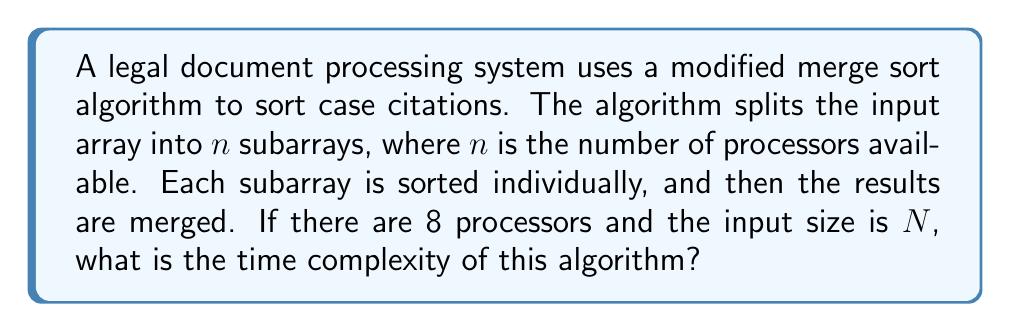Could you help me with this problem? To analyze the time complexity of this modified merge sort algorithm, we need to consider the following steps:

1. Splitting the input:
   The input of size $N$ is split into 8 subarrays (since there are 8 processors). This operation takes $O(N)$ time.

2. Sorting subarrays:
   Each subarray has a size of approximately $N/8$. Sorting each subarray using a standard merge sort algorithm takes $O((N/8) \log (N/8))$ time. Since this is done in parallel on 8 processors, the time complexity for this step remains $O((N/8) \log (N/8))$.

3. Merging the results:
   Merging 8 sorted subarrays of size $N/8$ each takes $O(N \log 8)$ time.

The total time complexity is the sum of these steps:

$$T(N) = O(N) + O((N/8) \log (N/8)) + O(N \log 8)$$

Simplifying:
1. $O(N)$ is lower order than the other terms and can be ignored in the final complexity.
2. $O((N/8) \log (N/8))$ can be simplified to $O(N \log N - N \log 8)$.
3. $O(N \log 8)$ is lower order than $O(N \log N)$ and can be combined.

Therefore, the dominant term is $O(N \log N)$, which determines the overall time complexity of the algorithm.
Answer: The time complexity of the modified merge sort algorithm is $O(N \log N)$. 